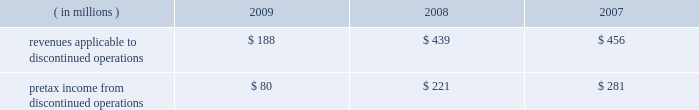Marathon oil corporation notes to consolidated financial statements been reported as discontinued operations in the consolidated statements of income and the consolidated statements of cash flows for all periods presented .
Discontinued operations 2014revenues and pretax income associated with our discontinued irish and gabonese operations are shown in the table : ( in millions ) 2009 2008 2007 .
Angola disposition 2013 in july 2009 , we entered into an agreement to sell an undivided 20 percent outside- operated interest in the production sharing contract and joint operating agreement in block 32 offshore angola for $ 1.3 billion , excluding any purchase price adjustments at closing , with an effective date of january 1 , 2009 .
The sale closed and we received net proceeds of $ 1.3 billion in february 2010 .
The pretax gain on the sale will be approximately $ 800 million .
We retained a 10 percent outside-operated interest in block 32 .
Gabon disposition 2013 in december 2009 , we closed the sale of our operated fields offshore gabon , receiving net proceeds of $ 269 million , after closing adjustments .
A $ 232 million pretax gain on this disposition was reported in discontinued operations for 2009 .
Permian basin disposition 2013 in june 2009 , we closed the sale of our operated and a portion of our outside- operated permian basin producing assets in new mexico and west texas for net proceeds after closing adjustments of $ 293 million .
A $ 196 million pretax gain on the sale was recorded .
Ireland dispositions 2013 in april 2009 , we closed the sale of our operated properties in ireland for net proceeds of $ 84 million , after adjusting for cash held by the sold subsidiary .
A $ 158 million pretax gain on the sale was recorded .
As a result of this sale , we terminated our pension plan in ireland , incurring a charge of $ 18 million .
In june 2009 , we entered into an agreement to sell the subsidiary holding our 19 percent outside-operated interest in the corrib natural gas development offshore ireland .
Total proceeds were estimated to range between $ 235 million and $ 400 million , subject to the timing of first commercial gas at corrib and closing adjustments .
At closing on july 30 , 2009 , the initial $ 100 million payment plus closing adjustments was received .
The fair value of the proceeds was estimated to be $ 311 million .
Fair value of anticipated sale proceeds includes ( i ) $ 100 million received at closing , ( ii ) $ 135 million minimum amount due at the earlier of first gas or december 31 , 2012 , and ( iii ) a range of zero to $ 165 million of contingent proceeds subject to the timing of first commercial gas .
A $ 154 million impairment of the held for sale asset was recognized in discontinued operations in the second quarter of 2009 ( see note 16 ) since the fair value of the disposal group was less than the net book value .
Final proceeds will range between $ 135 million ( minimum amount ) to $ 300 million and are due on the earlier of first commercial gas or december 31 , 2012 .
The fair value of the expected final proceeds was recorded as an asset at closing .
As a result of new public information in the fourth quarter of 2009 , a writeoff was recorded on the contingent portion of the proceeds ( see note 10 ) .
Existing guarantees of our subsidiaries 2019 performance issued to irish government entities will remain in place after the sales until the purchasers issue similar guarantees to replace them .
The guarantees , related to asset retirement obligations and natural gas production levels , have been indemnified by the purchasers .
The fair value of these guarantees is not significant .
Norwegian disposition 2013 on october 31 , 2008 , we closed the sale of our norwegian outside-operated e&p properties and undeveloped offshore acreage in the heimdal area of the norwegian north sea for net proceeds of $ 301 million , with a pretax gain of $ 254 million as of december 31 , 2008 .
Pilot travel centers disposition 2013 on october 8 , 2008 , we completed the sale of our 50 percent ownership interest in ptc .
Sale proceeds were $ 625 million , with a pretax gain on the sale of $ 126 million .
Immediately preceding the sale , we received a $ 75 million partial redemption of our ownership interest from ptc that was accounted for as a return of investment .
This was an investment of our rm&t segment. .
By how much did pretax income from discontinued operations decrease from 2007 to 2009? 
Computations: ((80 - 281) / 281)
Answer: -0.7153. 